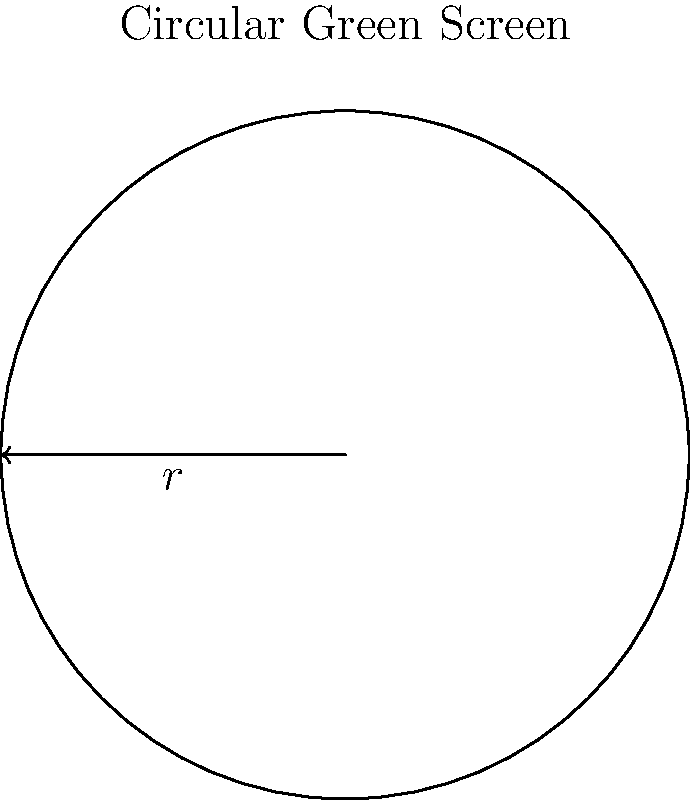As an aspiring Scottish film director, you're planning to use a circular green screen for your next project. The circumference of the green screen measures 18.85 meters. What is the radius of this circular green screen, rounded to two decimal places? To find the radius of the circular green screen, we'll use the formula for the circumference of a circle and solve for the radius. Here's the step-by-step process:

1) The formula for the circumference of a circle is:
   $$C = 2\pi r$$
   where $C$ is the circumference and $r$ is the radius.

2) We're given that the circumference is 18.85 meters. Let's substitute this into our equation:
   $$18.85 = 2\pi r$$

3) To solve for $r$, we need to divide both sides by $2\pi$:
   $$\frac{18.85}{2\pi} = r$$

4) Let's calculate this:
   $$r = \frac{18.85}{2\pi} \approx 3.00079 \text{ meters}$$

5) Rounding to two decimal places:
   $$r \approx 3.00 \text{ meters}$$

Thus, the radius of the circular green screen is approximately 3.00 meters.
Answer: 3.00 meters 